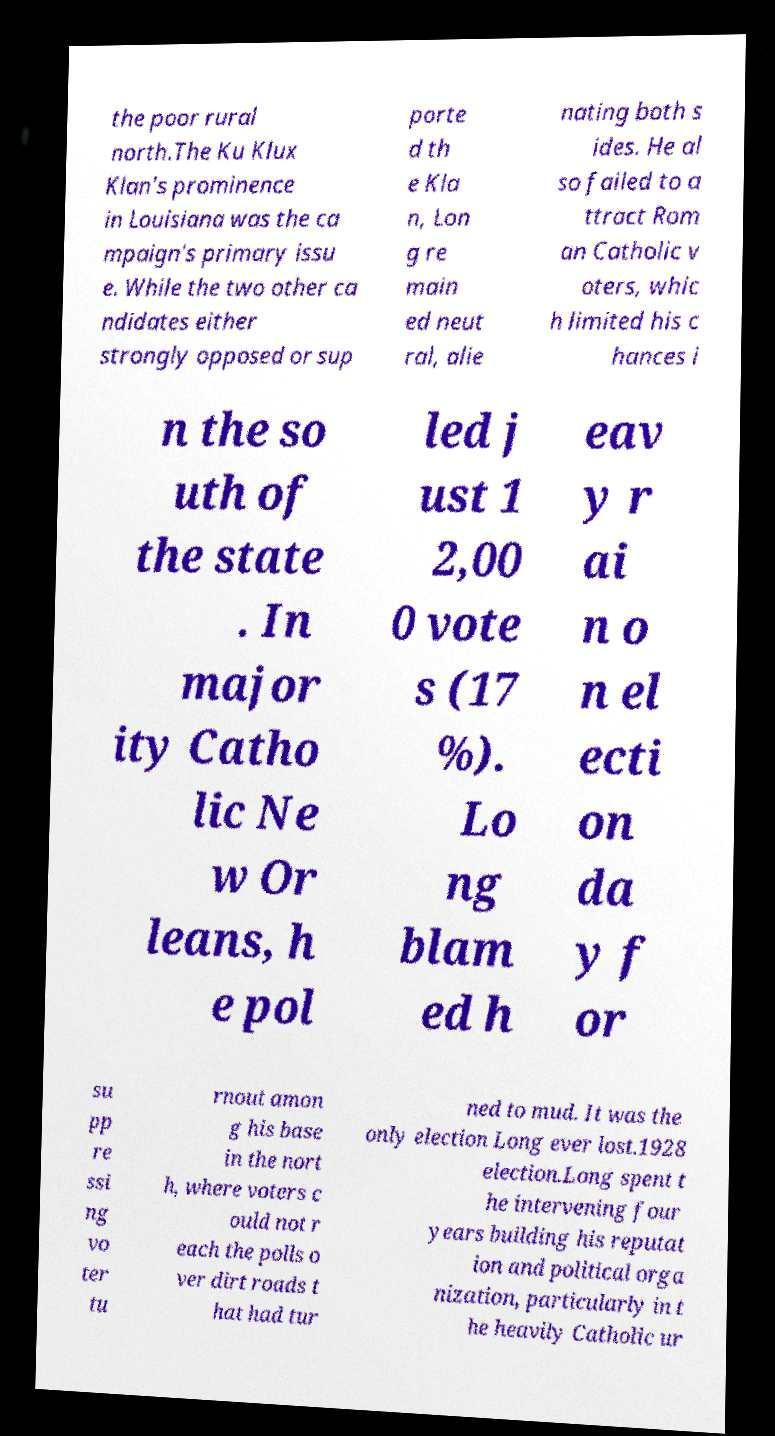Could you assist in decoding the text presented in this image and type it out clearly? the poor rural north.The Ku Klux Klan's prominence in Louisiana was the ca mpaign's primary issu e. While the two other ca ndidates either strongly opposed or sup porte d th e Kla n, Lon g re main ed neut ral, alie nating both s ides. He al so failed to a ttract Rom an Catholic v oters, whic h limited his c hances i n the so uth of the state . In major ity Catho lic Ne w Or leans, h e pol led j ust 1 2,00 0 vote s (17 %). Lo ng blam ed h eav y r ai n o n el ecti on da y f or su pp re ssi ng vo ter tu rnout amon g his base in the nort h, where voters c ould not r each the polls o ver dirt roads t hat had tur ned to mud. It was the only election Long ever lost.1928 election.Long spent t he intervening four years building his reputat ion and political orga nization, particularly in t he heavily Catholic ur 